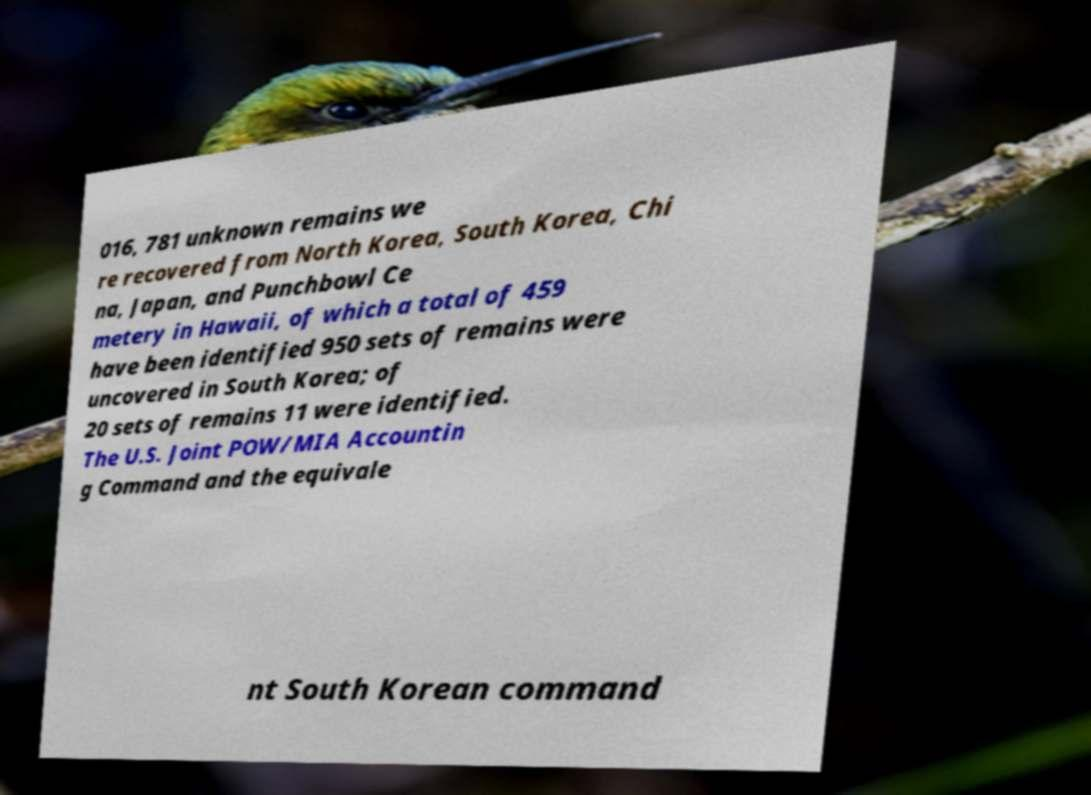There's text embedded in this image that I need extracted. Can you transcribe it verbatim? 016, 781 unknown remains we re recovered from North Korea, South Korea, Chi na, Japan, and Punchbowl Ce metery in Hawaii, of which a total of 459 have been identified 950 sets of remains were uncovered in South Korea; of 20 sets of remains 11 were identified. The U.S. Joint POW/MIA Accountin g Command and the equivale nt South Korean command 